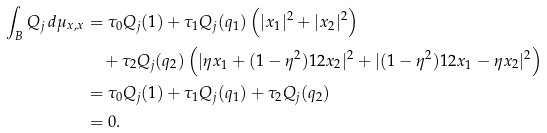<formula> <loc_0><loc_0><loc_500><loc_500>\int _ { B } Q _ { j } \, d \mu _ { x , x } & = \tau _ { 0 } Q _ { j } ( 1 ) + \tau _ { 1 } Q _ { j } ( q _ { 1 } ) \left ( | x _ { 1 } | ^ { 2 } + | x _ { 2 } | ^ { 2 } \right ) \\ & \quad + \tau _ { 2 } Q _ { j } ( q _ { 2 } ) \left ( | \eta x _ { 1 } + ( 1 - \eta ^ { 2 } ) ^ { } { 1 } 2 x _ { 2 } | ^ { 2 } + | ( 1 - \eta ^ { 2 } ) ^ { } { 1 } 2 x _ { 1 } - \eta x _ { 2 } | ^ { 2 } \right ) \\ & = \tau _ { 0 } Q _ { j } ( 1 ) + \tau _ { 1 } Q _ { j } ( q _ { 1 } ) + \tau _ { 2 } Q _ { j } ( q _ { 2 } ) \\ & = 0 .</formula> 